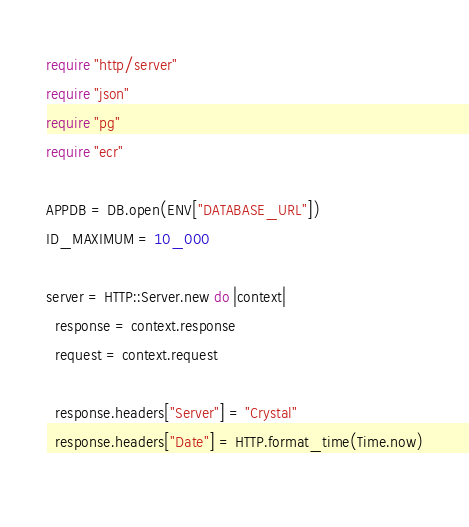<code> <loc_0><loc_0><loc_500><loc_500><_Crystal_>require "http/server"
require "json"
require "pg"
require "ecr"

APPDB = DB.open(ENV["DATABASE_URL"])
ID_MAXIMUM = 10_000

server = HTTP::Server.new do |context|
  response = context.response
  request = context.request

  response.headers["Server"] = "Crystal"
  response.headers["Date"] = HTTP.format_time(Time.now)
  </code> 